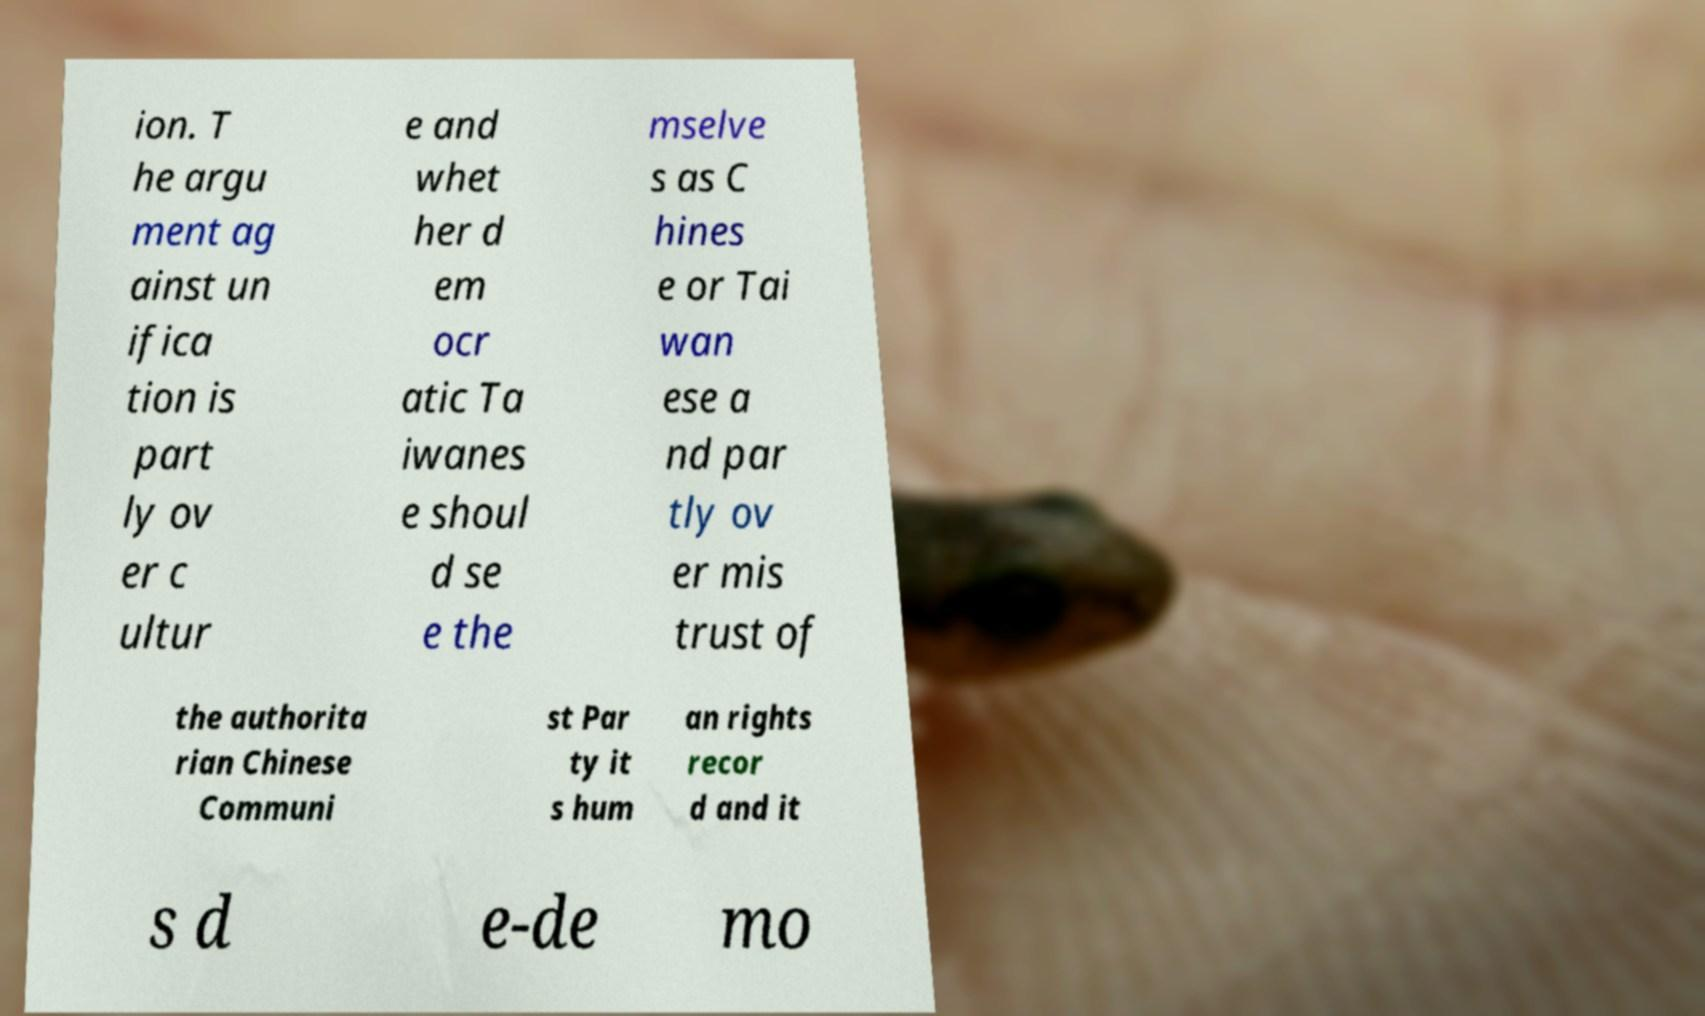Can you accurately transcribe the text from the provided image for me? ion. T he argu ment ag ainst un ifica tion is part ly ov er c ultur e and whet her d em ocr atic Ta iwanes e shoul d se e the mselve s as C hines e or Tai wan ese a nd par tly ov er mis trust of the authorita rian Chinese Communi st Par ty it s hum an rights recor d and it s d e-de mo 